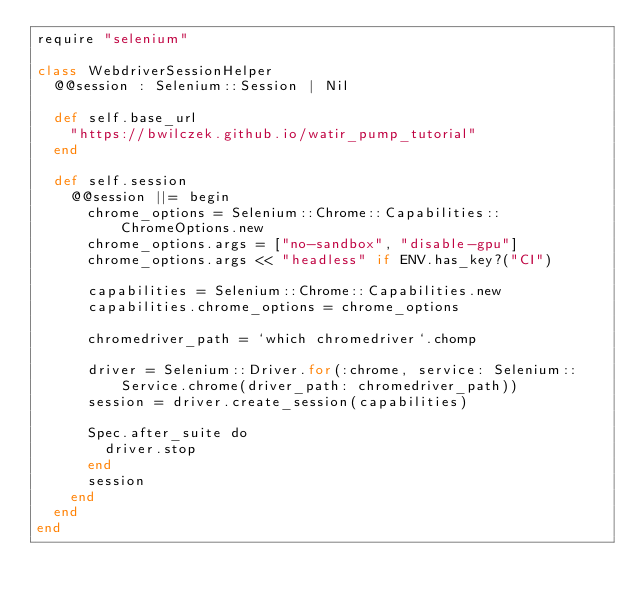<code> <loc_0><loc_0><loc_500><loc_500><_Crystal_>require "selenium"

class WebdriverSessionHelper
  @@session : Selenium::Session | Nil

  def self.base_url
    "https://bwilczek.github.io/watir_pump_tutorial"
  end

  def self.session
    @@session ||= begin
      chrome_options = Selenium::Chrome::Capabilities::ChromeOptions.new
      chrome_options.args = ["no-sandbox", "disable-gpu"]
      chrome_options.args << "headless" if ENV.has_key?("CI")

      capabilities = Selenium::Chrome::Capabilities.new
      capabilities.chrome_options = chrome_options

      chromedriver_path = `which chromedriver`.chomp

      driver = Selenium::Driver.for(:chrome, service: Selenium::Service.chrome(driver_path: chromedriver_path))
      session = driver.create_session(capabilities)

      Spec.after_suite do
        driver.stop
      end
      session
    end
  end
end
</code> 